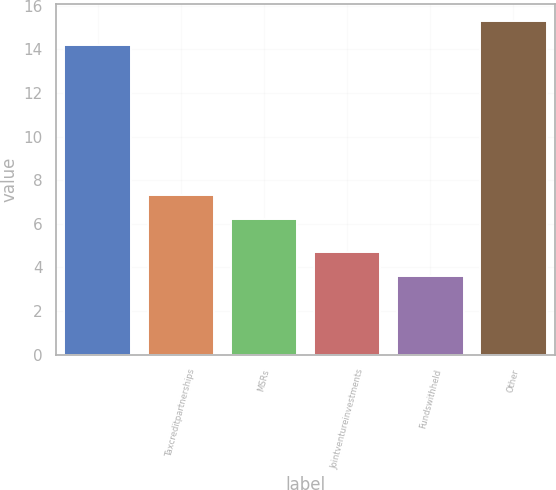Convert chart to OTSL. <chart><loc_0><loc_0><loc_500><loc_500><bar_chart><ecel><fcel>Taxcreditpartnerships<fcel>MSRs<fcel>Jointventureinvestments<fcel>Fundswithheld<fcel>Other<nl><fcel>14.2<fcel>7.32<fcel>6.2<fcel>4.72<fcel>3.6<fcel>15.32<nl></chart> 